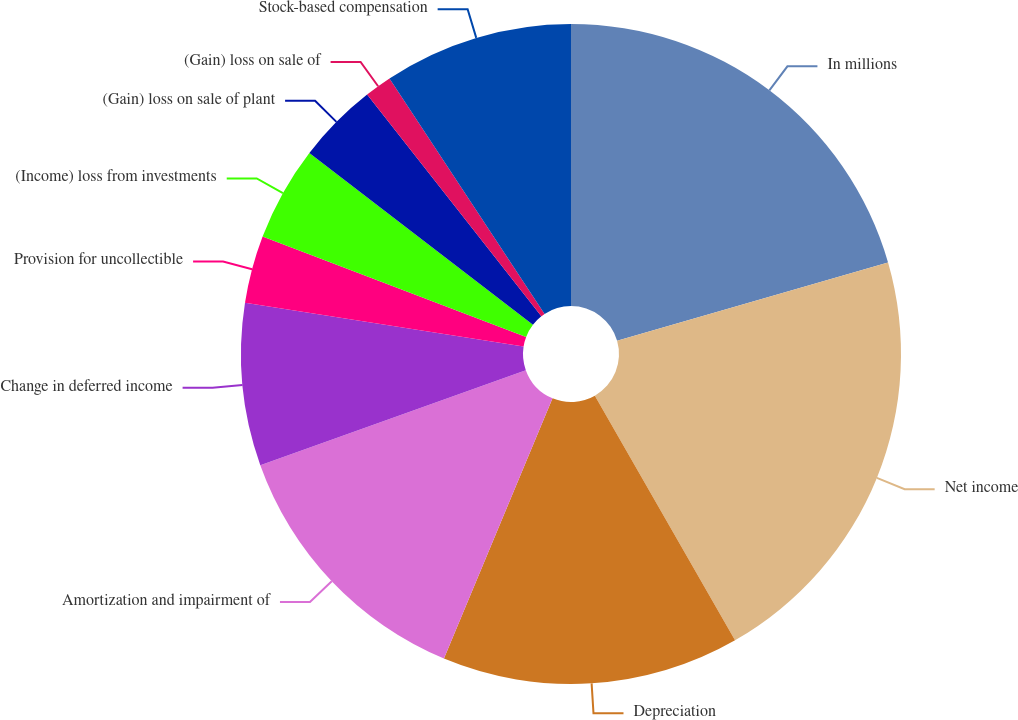Convert chart to OTSL. <chart><loc_0><loc_0><loc_500><loc_500><pie_chart><fcel>In millions<fcel>Net income<fcel>Depreciation<fcel>Amortization and impairment of<fcel>Change in deferred income<fcel>Provision for uncollectible<fcel>(Income) loss from investments<fcel>(Gain) loss on sale of plant<fcel>(Gain) loss on sale of<fcel>Stock-based compensation<nl><fcel>20.53%<fcel>21.19%<fcel>14.57%<fcel>13.24%<fcel>7.95%<fcel>3.31%<fcel>4.64%<fcel>3.97%<fcel>1.33%<fcel>9.27%<nl></chart> 